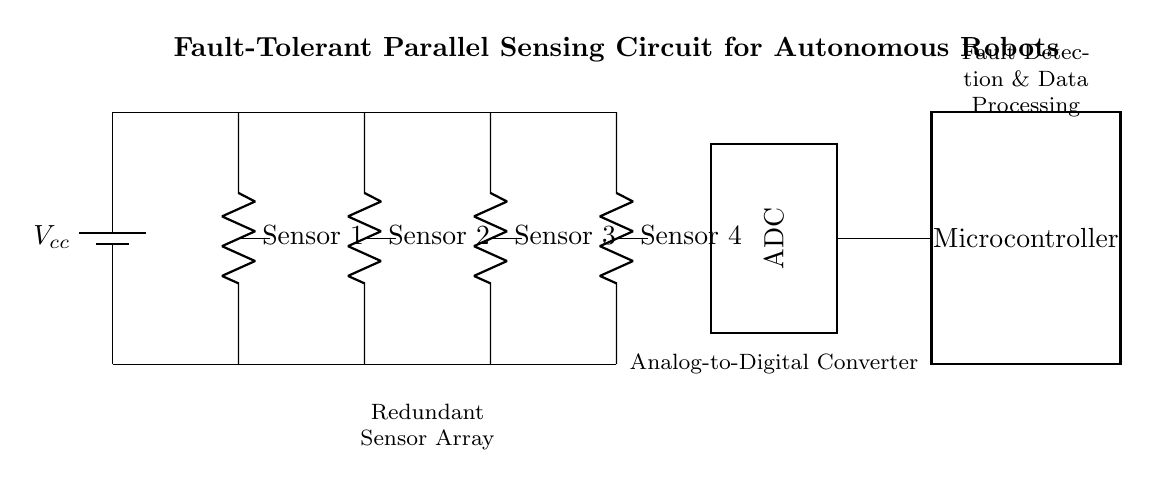What type of circuit is presented? The circuit is a sensing circuit with parallel arrangements for redundancy in sensor arrays. The arrangement of sensors in parallel allows for multiple inputs to operate concurrently, providing fault tolerance.
Answer: Parallel sensing circuit How many sensors are there in the circuit? There are four sensors labeled as Sensor 1, Sensor 2, Sensor 3, and Sensor 4. Each sensor is connected in parallel to the main supply, contributing to redundancy.
Answer: Four What is the function of the ADC in this circuit? The Analog-to-Digital Converter (ADC) converts the analog signals from the sensors into digital signals that can be processed by the microcontroller. This is crucial for data analysis and fault detection.
Answer: Conversion of analog signals Identify the main processing unit in the circuit. The microcontroller is the main processing unit that receives data from the ADC. It is responsible for processing the signals and managing the system's response, including fault detection.
Answer: Microcontroller Which component ensures data redundancy? The redundant sensor array itself ensures data redundancy by having multiple sensors that can provide the same input. If one sensor fails, others can still supply accurate readings.
Answer: Redundant sensor array What role does the power supply play in this circuit? The power supply provides the necessary voltage to operate all the components, including the sensors, ADC, and microcontroller. Consistent voltage is essential for proper circuit functionality.
Answer: Supply voltage 